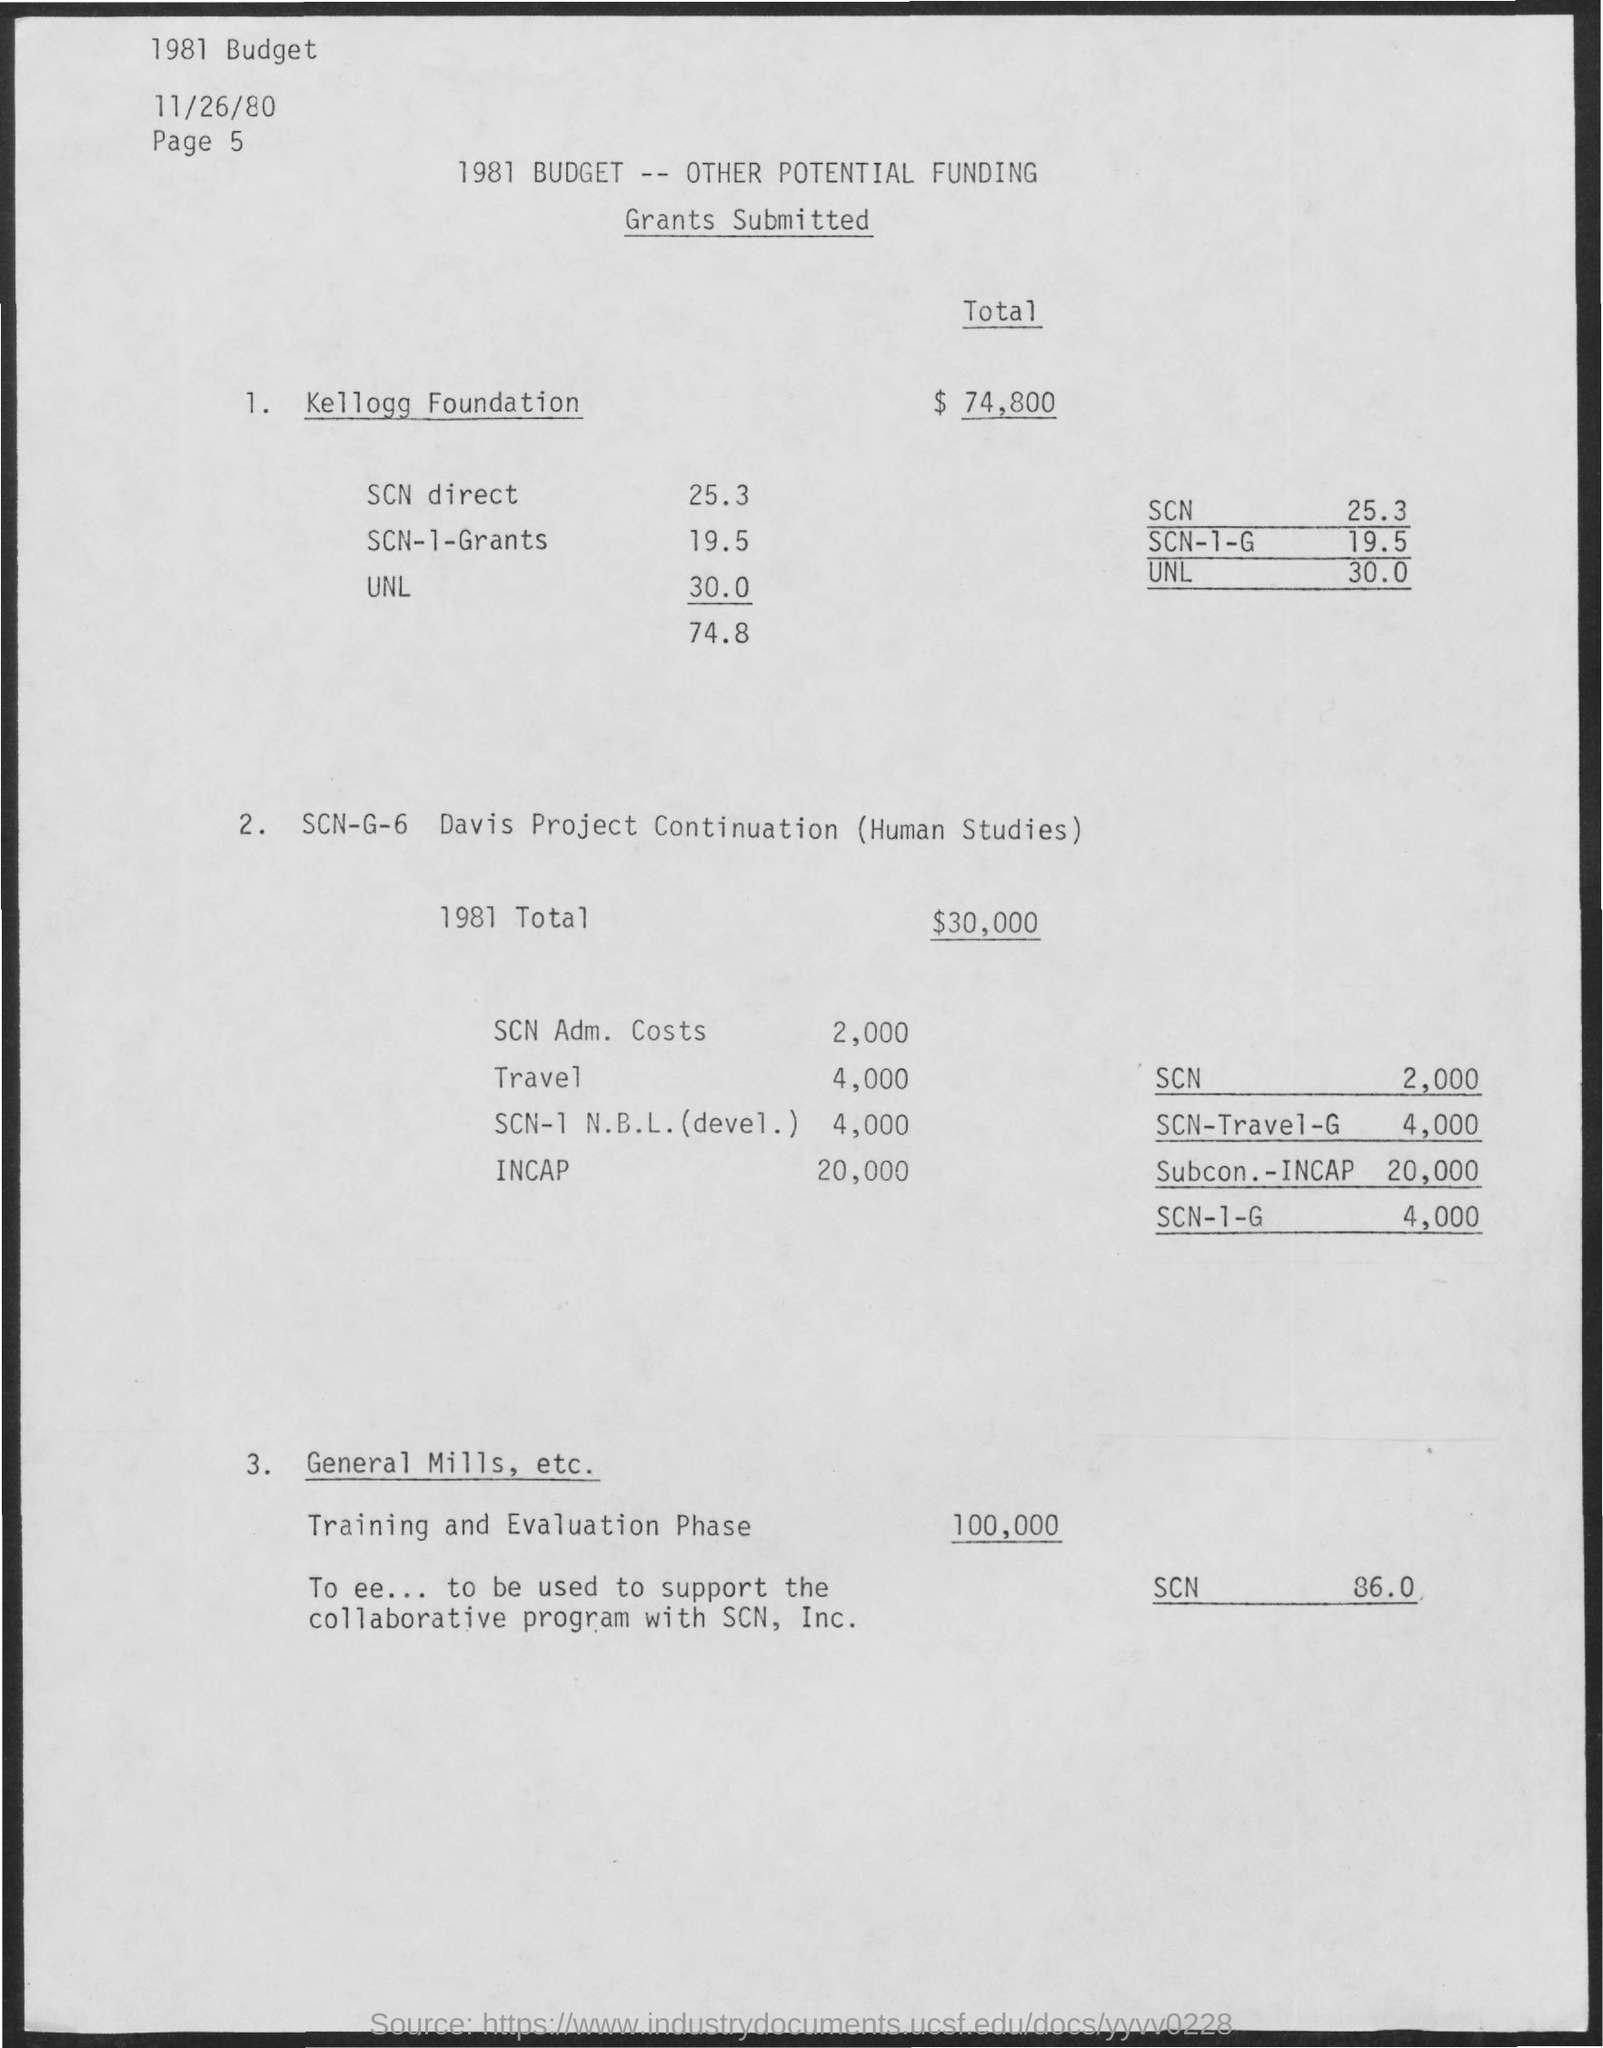Total fund for training and evaluation phase? The total funding allocated for the training and evaluation phase, as outlined in the document, is $100,000. This sum is earmarked for supporting the collaborative program with SCN, Inc. 